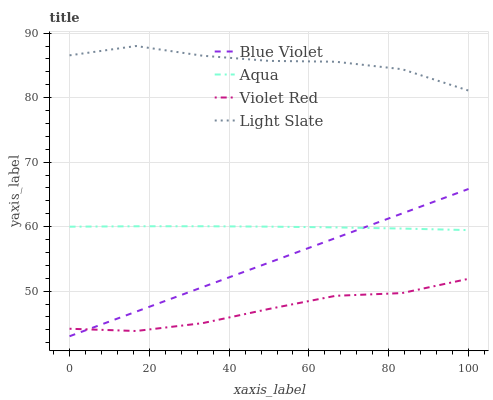Does Aqua have the minimum area under the curve?
Answer yes or no. No. Does Aqua have the maximum area under the curve?
Answer yes or no. No. Is Violet Red the smoothest?
Answer yes or no. No. Is Violet Red the roughest?
Answer yes or no. No. Does Violet Red have the lowest value?
Answer yes or no. No. Does Aqua have the highest value?
Answer yes or no. No. Is Aqua less than Light Slate?
Answer yes or no. Yes. Is Light Slate greater than Blue Violet?
Answer yes or no. Yes. Does Aqua intersect Light Slate?
Answer yes or no. No. 